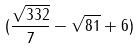Convert formula to latex. <formula><loc_0><loc_0><loc_500><loc_500>( \frac { \sqrt { 3 3 2 } } { 7 } - \sqrt { 8 1 } + 6 )</formula> 